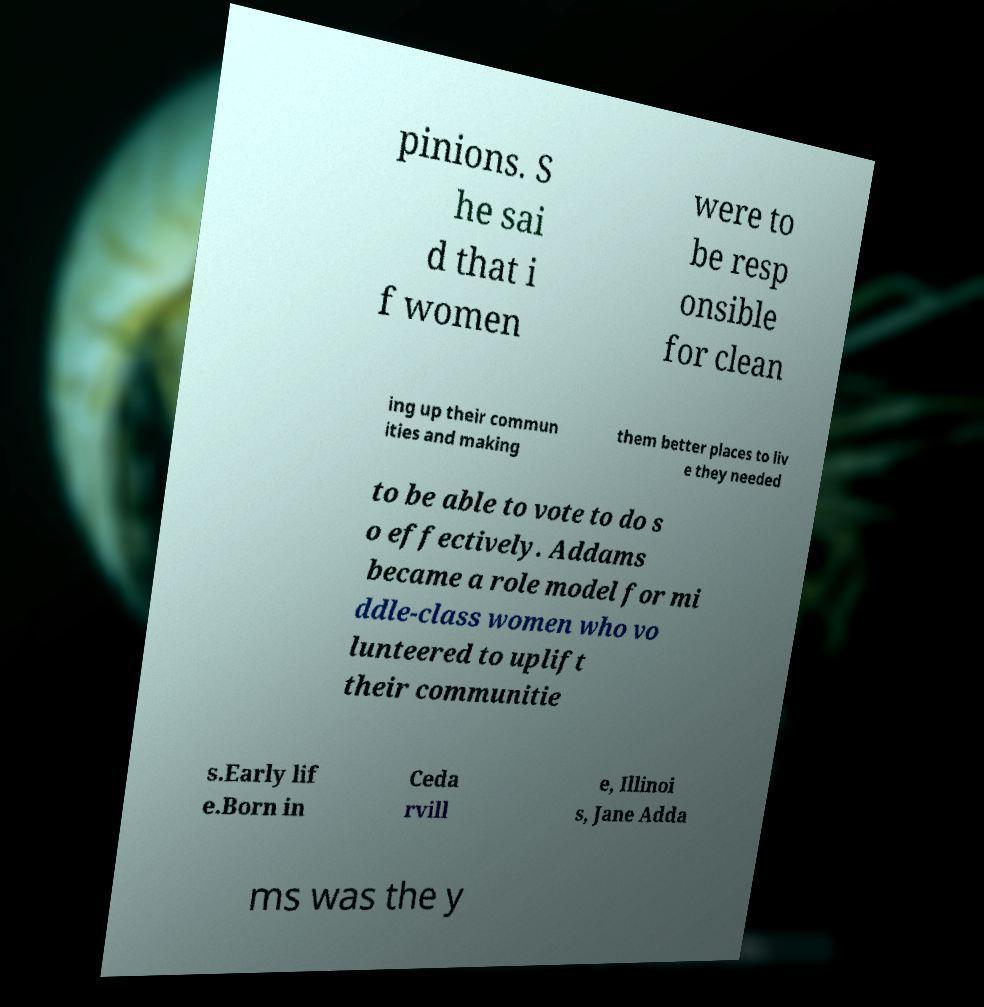Can you read and provide the text displayed in the image?This photo seems to have some interesting text. Can you extract and type it out for me? pinions. S he sai d that i f women were to be resp onsible for clean ing up their commun ities and making them better places to liv e they needed to be able to vote to do s o effectively. Addams became a role model for mi ddle-class women who vo lunteered to uplift their communitie s.Early lif e.Born in Ceda rvill e, Illinoi s, Jane Adda ms was the y 